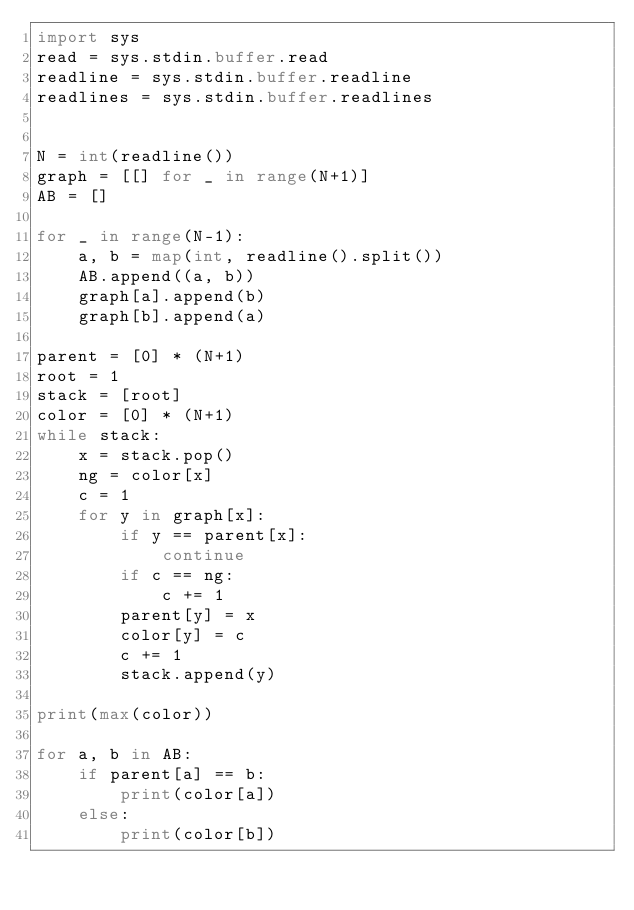Convert code to text. <code><loc_0><loc_0><loc_500><loc_500><_Python_>import sys
read = sys.stdin.buffer.read
readline = sys.stdin.buffer.readline
readlines = sys.stdin.buffer.readlines


N = int(readline())
graph = [[] for _ in range(N+1)]
AB = []

for _ in range(N-1):
    a, b = map(int, readline().split())
    AB.append((a, b))
    graph[a].append(b)
    graph[b].append(a)

parent = [0] * (N+1)
root = 1
stack = [root]
color = [0] * (N+1)
while stack:
    x = stack.pop()
    ng = color[x]
    c = 1
    for y in graph[x]:
        if y == parent[x]:
            continue
        if c == ng:
            c += 1
        parent[y] = x
        color[y] = c
        c += 1
        stack.append(y)

print(max(color))

for a, b in AB:
    if parent[a] == b:
        print(color[a])
    else:
        print(color[b])</code> 